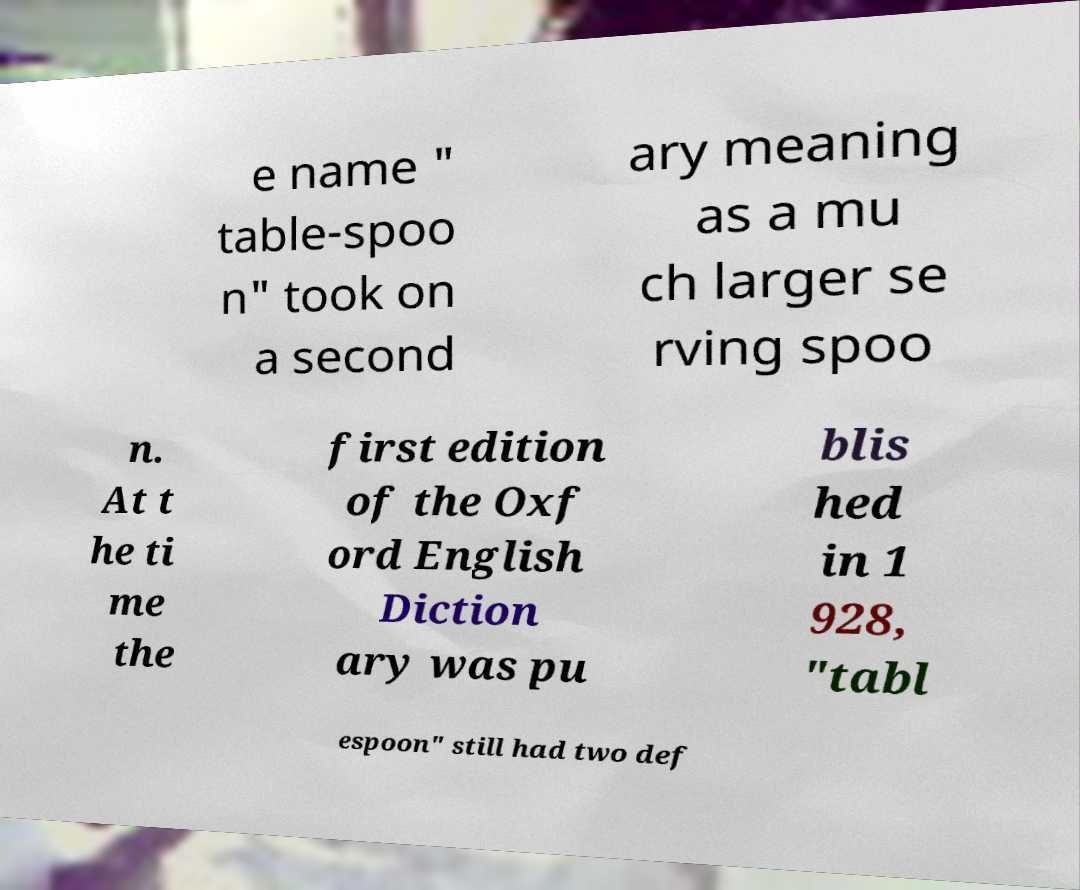There's text embedded in this image that I need extracted. Can you transcribe it verbatim? e name " table-spoo n" took on a second ary meaning as a mu ch larger se rving spoo n. At t he ti me the first edition of the Oxf ord English Diction ary was pu blis hed in 1 928, "tabl espoon" still had two def 